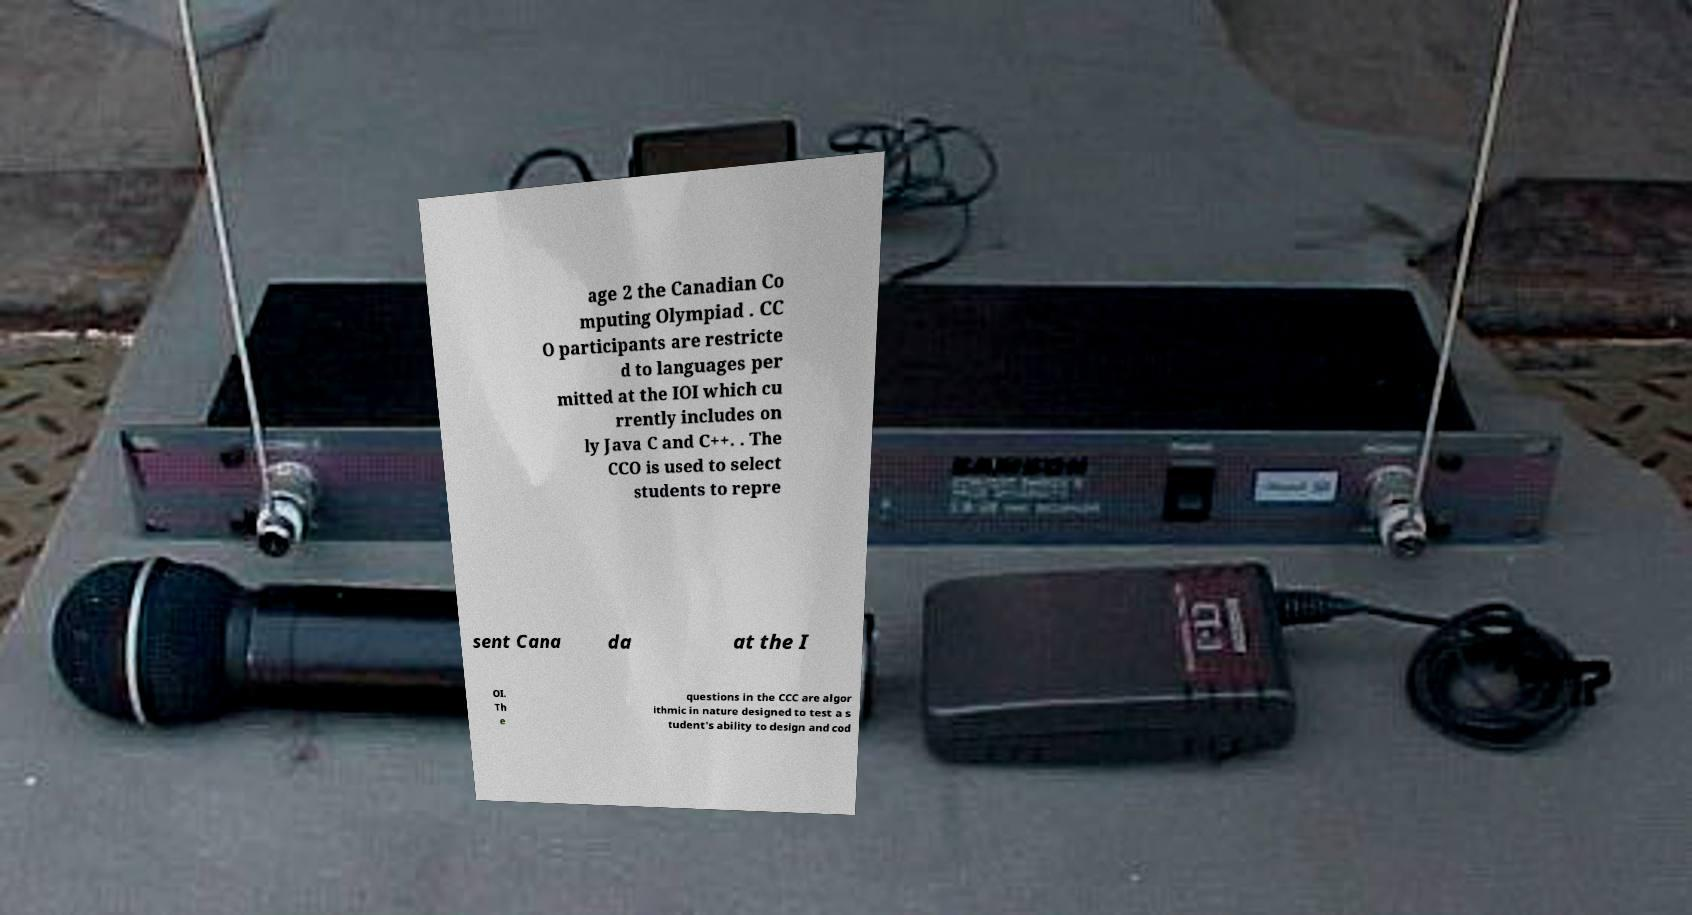I need the written content from this picture converted into text. Can you do that? age 2 the Canadian Co mputing Olympiad . CC O participants are restricte d to languages per mitted at the IOI which cu rrently includes on ly Java C and C++. . The CCO is used to select students to repre sent Cana da at the I OI. Th e questions in the CCC are algor ithmic in nature designed to test a s tudent's ability to design and cod 